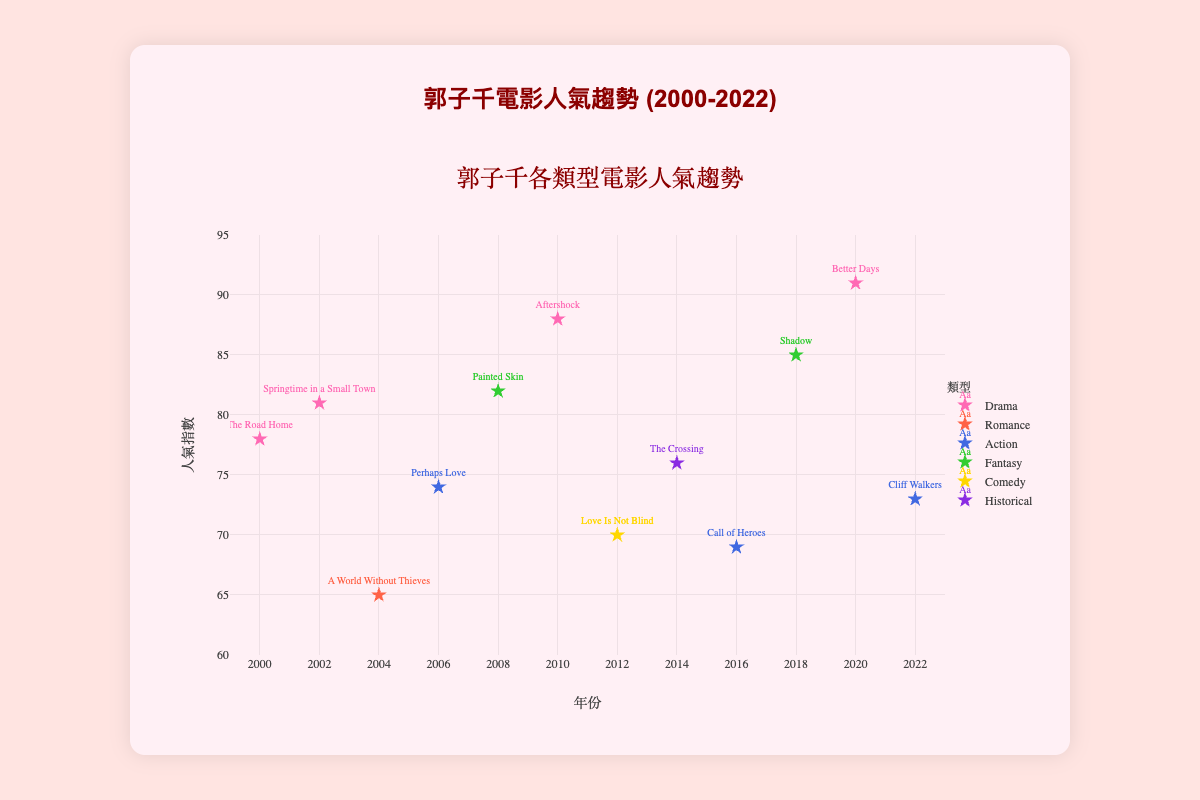How many movies are shown in the figure for the genre "Drama"? To find out how many "Drama" movies there are, look at the legend to identify the color assigned to "Drama", then count the points with this color in the chart.
Answer: 4 What trend can you observe in Kuo Tzu-chien's movies' popularity over the years? To identify the trend, look at the distribution of the points across the years along the X-axis and how their Y-coordinates change. You’ll notice there's an upward trend in the popularity index as years progress.
Answer: Increasing Which genre has the highest peak in popularity index, and what is the value? First, identify all genres and compare their highest points on the Y-axis. The "Drama" genre has the highest peak with "Better Days" in 2020, which reaches a popularity index of 91.
Answer: Drama, 91 How many genres are represented in the figure? Look at the legend in the figure to count the total number of different genres listed.
Answer: 6 Which movie released in 2012 has a popularity index of 70? Find the data point corresponding to 2012 on the X-axis. Hover over the point to see the movie title which is "Love Is Not Blind" with the popularity index of 70.
Answer: Love Is Not Blind If you consider only the genre "Action," what is the average popularity index of Kuo Tzu-chien's action movies? First, identify the popularity indices of all action movies: 74 (Perhaps Love), 69 (Call of Heroes), and 73 (Cliff Walkers). Add these indices together and then divide by the number of movies: \( (74 + 69 + 73) / 3 = 72 \).
Answer: 72 Which genre has consistently high popularity over the years, and what indicates this trend? To determine consistency, review all genre trends individually. "Drama" shows high and consistent popularity indices throughout the years with all values being fairly high (78, 81, 88, and 91).
Answer: Drama Compare "Fantasy" movies' popularity in 2008 and 2018. What do you observe? Look at the popularity index for "Fantasy" genre in 2008 and 2018, observing that in 2008, “Painted Skin” reached 82, and in 2018, “Shadow” reached 85. The popularity increased over this period.
Answer: Increased Which year features the most number of movies from different genres? Count the number of distinct genres for each year by examining data points grouped by the same x-coordinate. 2010, 2014, and 2016 each have two different genre movies.
Answer: 2014 and 2016 What is the gap in the popularity index between Kuo Tzu-chien's least popular and most popular movies, and which movies are they? Find the highest and lowest points on the Y-axis and note the movie titles. The lowest is "A World Without Thieves" (65) and the highest is "Better Days" (91). The gap is \( 91 - 65 = 26 \).
Answer: 26 